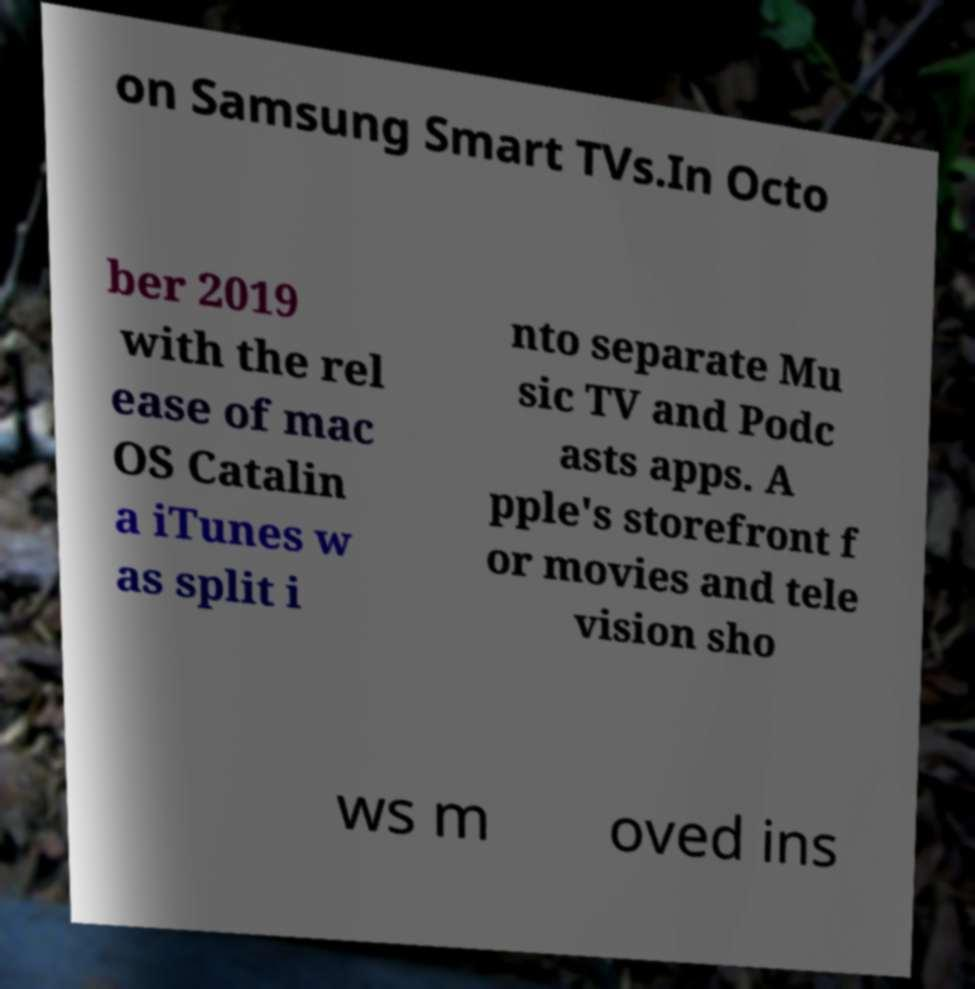There's text embedded in this image that I need extracted. Can you transcribe it verbatim? on Samsung Smart TVs.In Octo ber 2019 with the rel ease of mac OS Catalin a iTunes w as split i nto separate Mu sic TV and Podc asts apps. A pple's storefront f or movies and tele vision sho ws m oved ins 